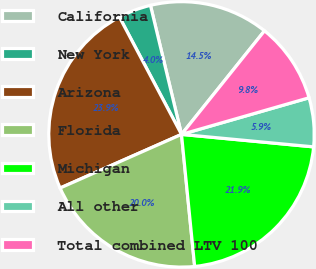<chart> <loc_0><loc_0><loc_500><loc_500><pie_chart><fcel>California<fcel>New York<fcel>Arizona<fcel>Florida<fcel>Michigan<fcel>All other<fcel>Total combined LTV 100<nl><fcel>14.51%<fcel>3.99%<fcel>23.88%<fcel>19.96%<fcel>21.92%<fcel>5.95%<fcel>9.8%<nl></chart> 